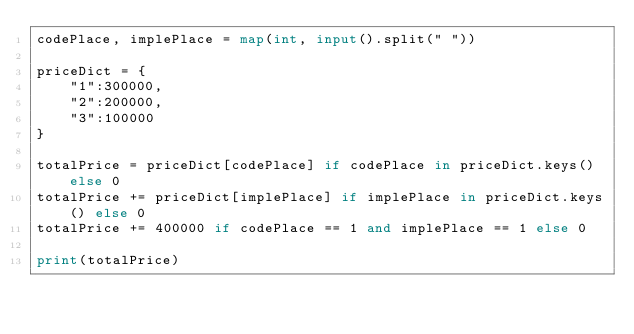Convert code to text. <code><loc_0><loc_0><loc_500><loc_500><_Python_>codePlace, implePlace = map(int, input().split(" "))

priceDict = {
    "1":300000,
    "2":200000,
    "3":100000
}

totalPrice = priceDict[codePlace] if codePlace in priceDict.keys() else 0
totalPrice += priceDict[implePlace] if implePlace in priceDict.keys() else 0
totalPrice += 400000 if codePlace == 1 and implePlace == 1 else 0

print(totalPrice)
</code> 